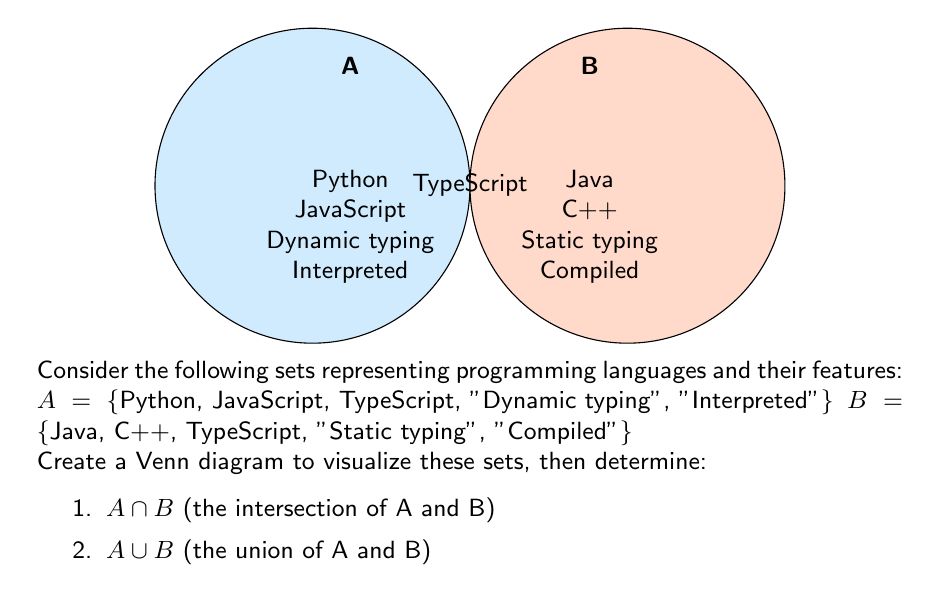Can you answer this question? Let's approach this step-by-step:

1. First, we need to identify the elements in each set:
   A = {Python, JavaScript, TypeScript, "Dynamic typing", "Interpreted"}
   B = {Java, C++, TypeScript, "Static typing", "Compiled"}

2. To find $A \cap B$ (the intersection), we need to identify elements that are in both sets:
   - The only element present in both A and B is "TypeScript"
   - Therefore, $A \cap B$ = {TypeScript}

3. To find $A \cup B$ (the union), we need to list all unique elements from both sets:
   - Start with all elements from A
   - Add elements from B that are not already in A
   - $A \cup B$ = {Python, JavaScript, TypeScript, "Dynamic typing", "Interpreted", Java, C++, "Static typing", "Compiled"}

4. Let's count the elements:
   - $|A \cap B| = 1$ (cardinality of the intersection)
   - $|A \cup B| = 9$ (cardinality of the union)

5. We can verify using the set theory formula:
   $|A \cup B| = |A| + |B| - |A \cap B|$
   $9 = 5 + 5 - 1$

This confirms our calculations are correct.
Answer: $A \cap B = \{TypeScript\}$
$A \cup B = \{Python, JavaScript, TypeScript, "Dynamic typing", "Interpreted", Java, C++, "Static typing", "Compiled"\}$ 